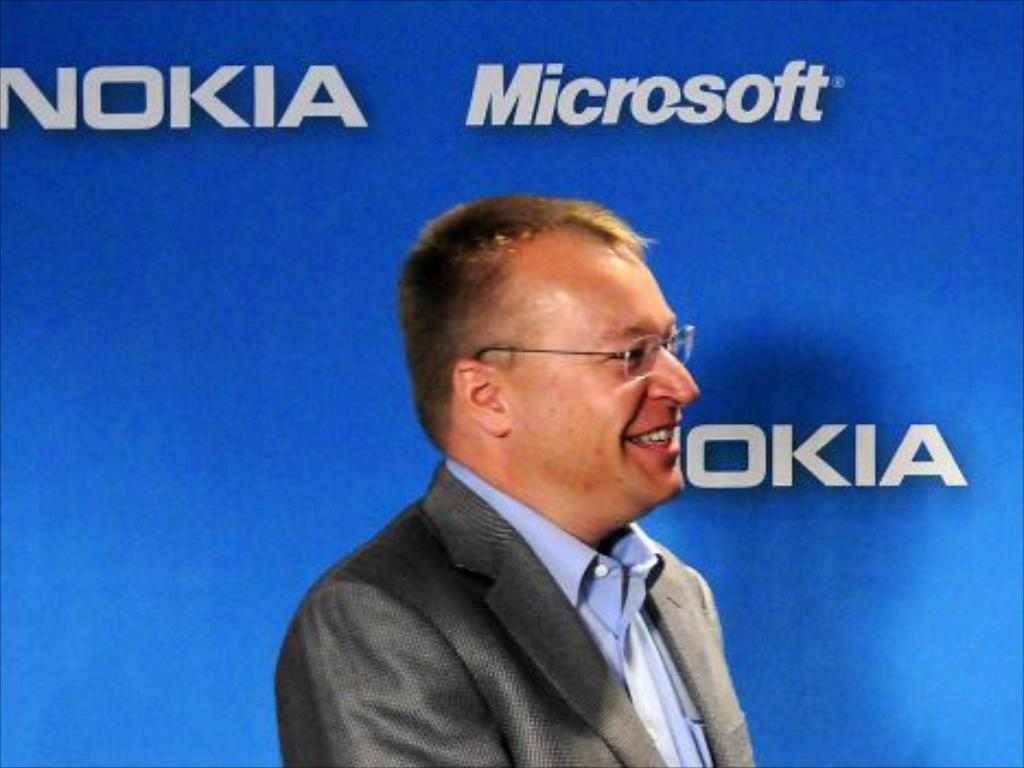<image>
Summarize the visual content of the image. A man in front of a wall which contains the names of technology companies such as Microsoft and Nokia. 